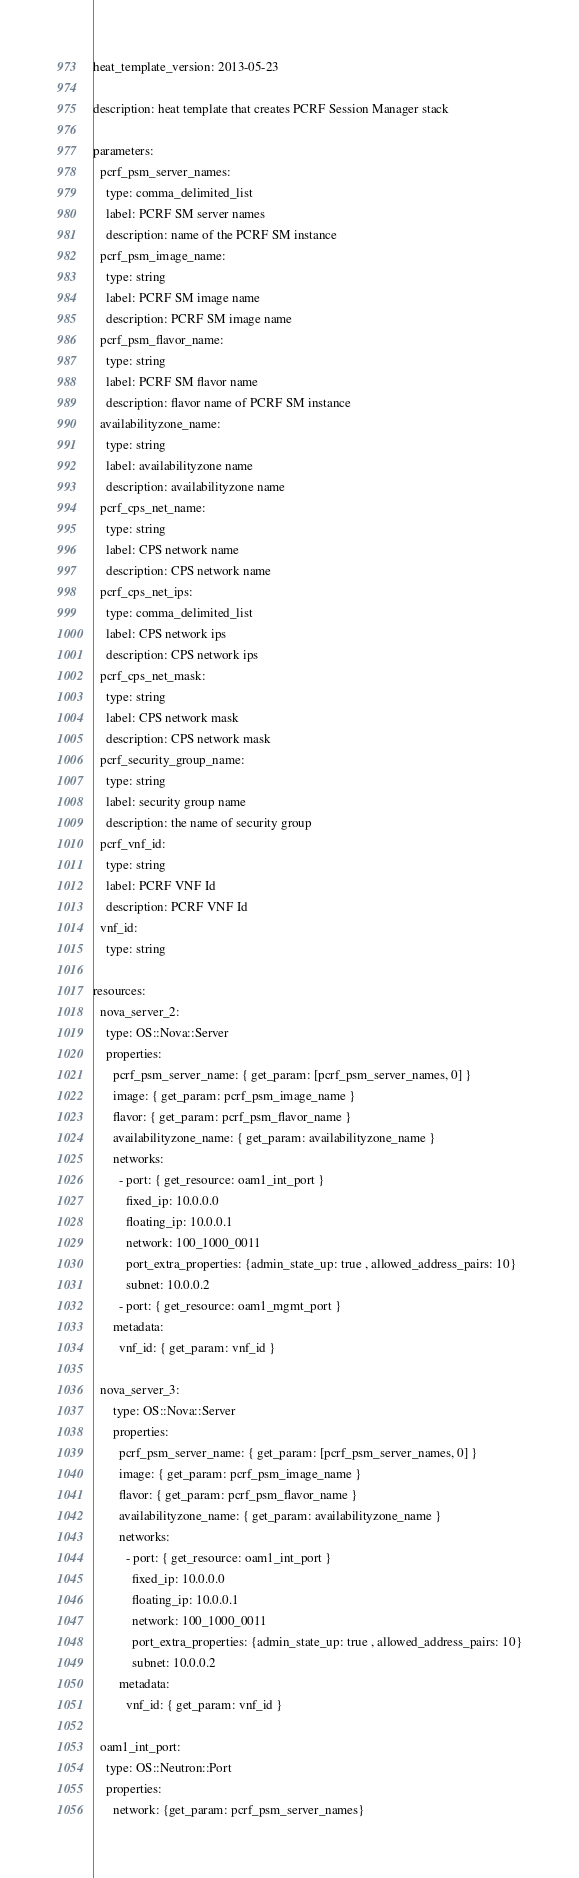<code> <loc_0><loc_0><loc_500><loc_500><_YAML_>heat_template_version: 2013-05-23

description: heat template that creates PCRF Session Manager stack

parameters:
  pcrf_psm_server_names:
    type: comma_delimited_list
    label: PCRF SM server names
    description: name of the PCRF SM instance
  pcrf_psm_image_name:
    type: string
    label: PCRF SM image name
    description: PCRF SM image name
  pcrf_psm_flavor_name:
    type: string
    label: PCRF SM flavor name
    description: flavor name of PCRF SM instance 
  availabilityzone_name:
    type: string
    label: availabilityzone name
    description: availabilityzone name
  pcrf_cps_net_name:
    type: string
    label: CPS network name
    description: CPS network name
  pcrf_cps_net_ips:
    type: comma_delimited_list
    label: CPS network ips
    description: CPS network ips
  pcrf_cps_net_mask:
    type: string
    label: CPS network mask
    description: CPS network mask
  pcrf_security_group_name:
    type: string
    label: security group name
    description: the name of security group
  pcrf_vnf_id:
    type: string
    label: PCRF VNF Id
    description: PCRF VNF Id
  vnf_id:
    type: string

resources:
  nova_server_2:
    type: OS::Nova::Server
    properties:
      pcrf_psm_server_name: { get_param: [pcrf_psm_server_names, 0] }
      image: { get_param: pcrf_psm_image_name }
      flavor: { get_param: pcrf_psm_flavor_name }
      availabilityzone_name: { get_param: availabilityzone_name }
      networks:
        - port: { get_resource: oam1_int_port }
          fixed_ip: 10.0.0.0
          floating_ip: 10.0.0.1
          network: 100_1000_0011
          port_extra_properties: {admin_state_up: true , allowed_address_pairs: 10}
          subnet: 10.0.0.2
        - port: { get_resource: oam1_mgmt_port }
      metadata:
        vnf_id: { get_param: vnf_id }

  nova_server_3:
      type: OS::Nova::Server
      properties:
        pcrf_psm_server_name: { get_param: [pcrf_psm_server_names, 0] }
        image: { get_param: pcrf_psm_image_name }
        flavor: { get_param: pcrf_psm_flavor_name }
        availabilityzone_name: { get_param: availabilityzone_name }
        networks:
          - port: { get_resource: oam1_int_port }
            fixed_ip: 10.0.0.0
            floating_ip: 10.0.0.1
            network: 100_1000_0011
            port_extra_properties: {admin_state_up: true , allowed_address_pairs: 10}
            subnet: 10.0.0.2
        metadata:
          vnf_id: { get_param: vnf_id }

  oam1_int_port:
    type: OS::Neutron::Port
    properties:
      network: {get_param: pcrf_psm_server_names}</code> 